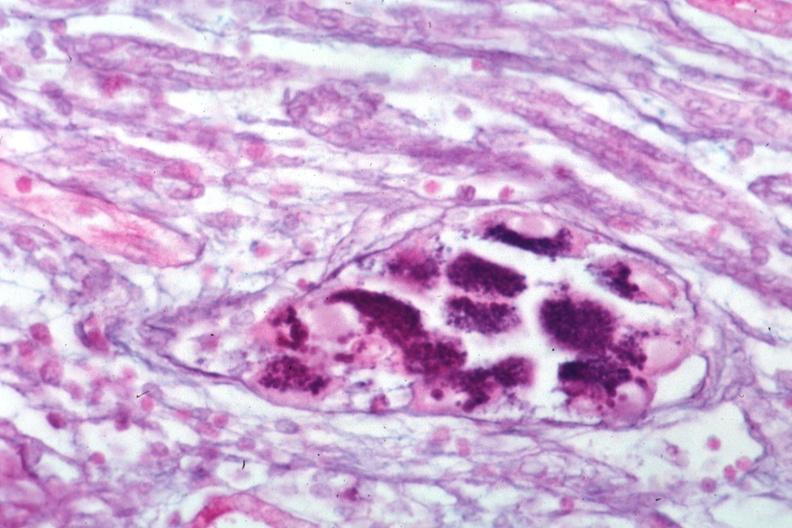s cytomegalovirus present?
Answer the question using a single word or phrase. Yes 